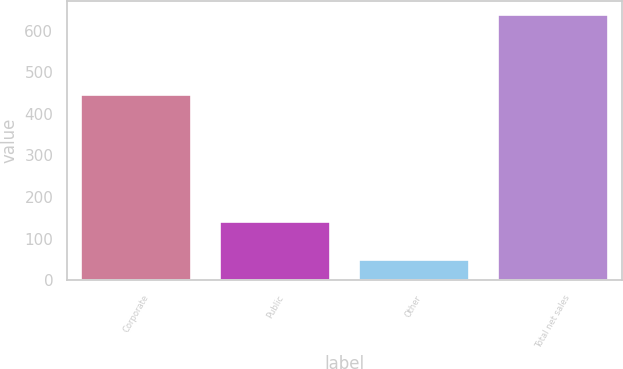Convert chart to OTSL. <chart><loc_0><loc_0><loc_500><loc_500><bar_chart><fcel>Corporate<fcel>Public<fcel>Other<fcel>Total net sales<nl><fcel>447.3<fcel>141.5<fcel>51.6<fcel>640.4<nl></chart> 